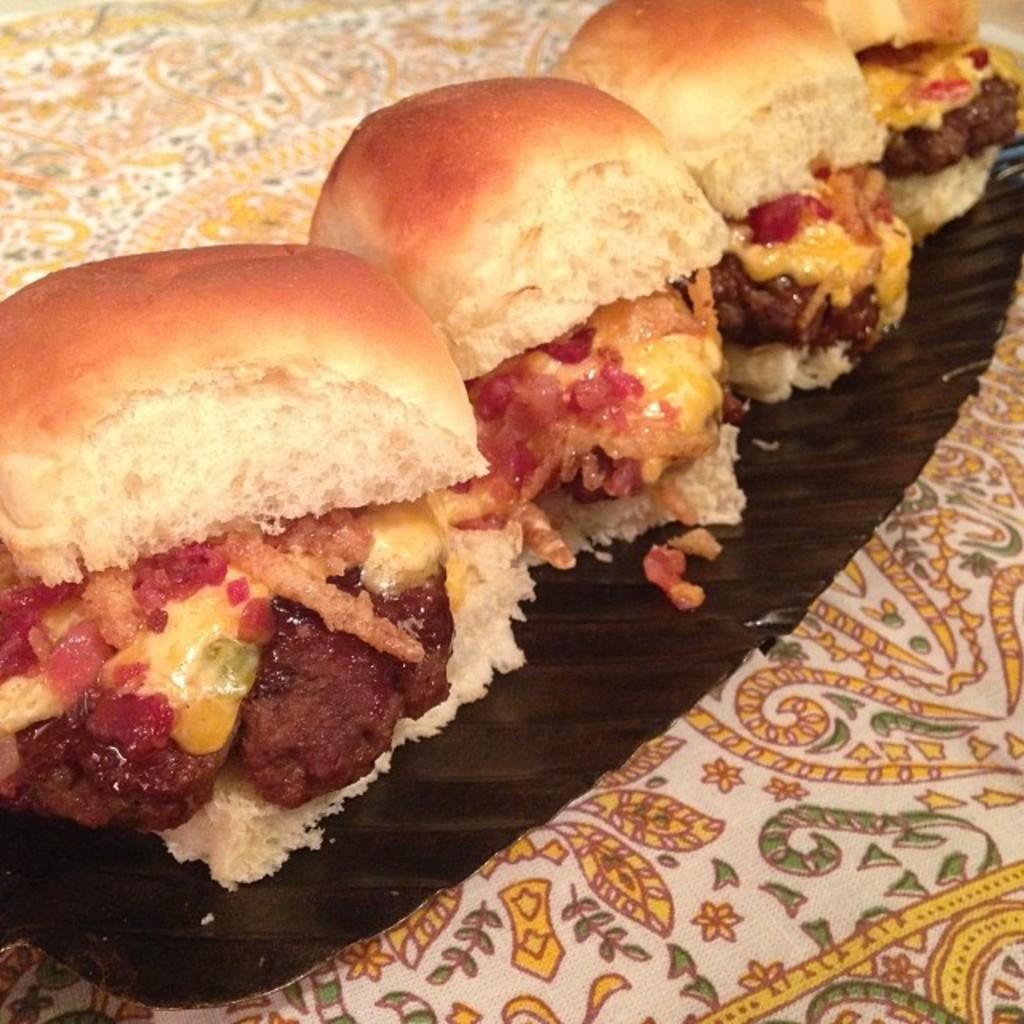Please provide a concise description of this image. In this picture, we can see a plate on a cloth and on the plate there are buns and some food items. 